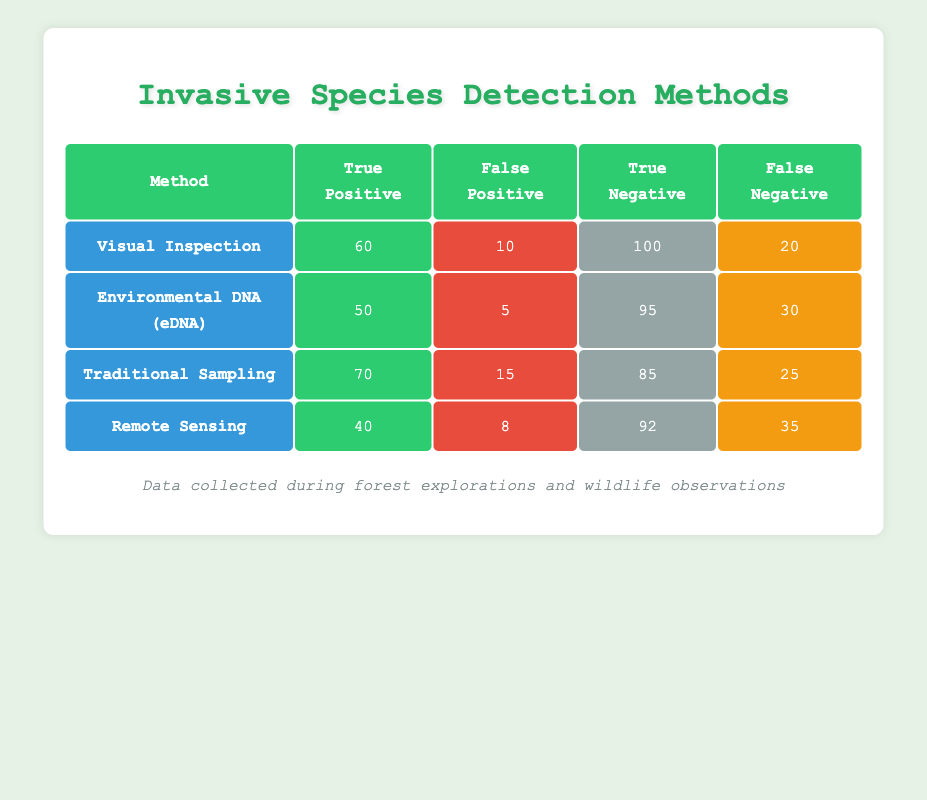What is the true positive count for Traditional Sampling? The table indicates that the true positive count for Traditional Sampling is 70. This value is found directly under the "True Positive" column for the row that lists Traditional Sampling as the method.
Answer: 70 Which invasive species detection method has the highest number of false negatives? From the table, we see that Remote Sensing has the highest number of false negatives, which is 35. This is determined by comparing the values in the "False Negative" column for each method, and Remote Sensing has the largest value among them.
Answer: Remote Sensing What is the total number of true positives across all methods? To find the total number of true positives, we add the true positive values from each method: 60 (Visual Inspection) + 50 (Environmental DNA) + 70 (Traditional Sampling) + 40 (Remote Sensing) = 220. Thus, the total true positives is 220.
Answer: 220 Is the number of false positives for Environmental DNA less than that for Traditional Sampling? The number of false positives for Environmental DNA is 5, while for Traditional Sampling it is 15. Since 5 is indeed less than 15, the statement is true.
Answer: Yes Which method has the highest overall accuracy, considering true positives and true negatives? To determine overall accuracy, calculate the sum of true positives and true negatives for each method and divide by the total number of samples (which is the sum of true positives, false positives, true negatives, and false negatives for each method). For each method: Visual Inspection = (60 + 100) / (60 + 10 + 100 + 20) = 160/190 = 0.842; Environmental DNA = (50 + 95) / (50 + 5 + 95 + 30) = 145/180 = 0.805; Traditional Sampling = (70 + 85) / (70 + 15 + 85 + 25) = 155/195 = 0.795; Remote Sensing = (40 + 92) / (40 + 8 + 92 + 35) = 132/175 = 0.754. The highest accuracy is from Visual Inspection, at approximately 84.2%.
Answer: Visual Inspection What is the difference in true negatives between Visual Inspection and Remote Sensing? The true negatives for Visual Inspection is 100 and for Remote Sensing is 92. The difference is calculated by subtracting the two values: 100 - 92 = 8. Thus, Visual Inspection has 8 more true negatives than Remote Sensing.
Answer: 8 